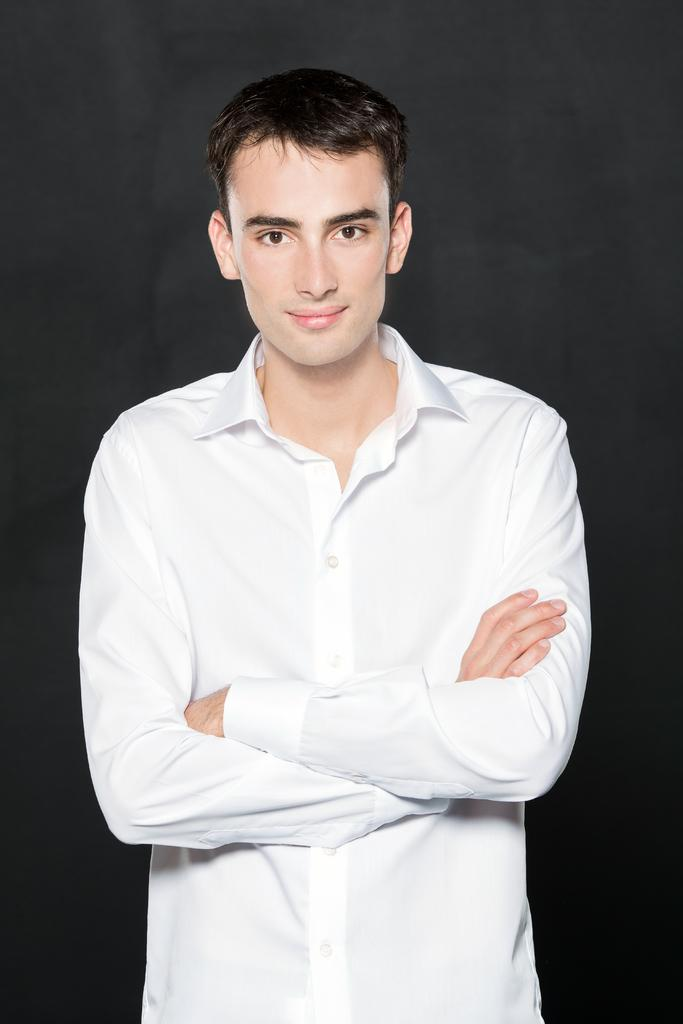What is the main subject of the image? There is a person in the image. What can be observed about the background of the image? The background of the image is dark. What type of pet can be seen assisting the person in the image? There is no pet present in the image. What type of spy equipment can be seen in the hands of the person in the image? There is no spy equipment visible in the image. 